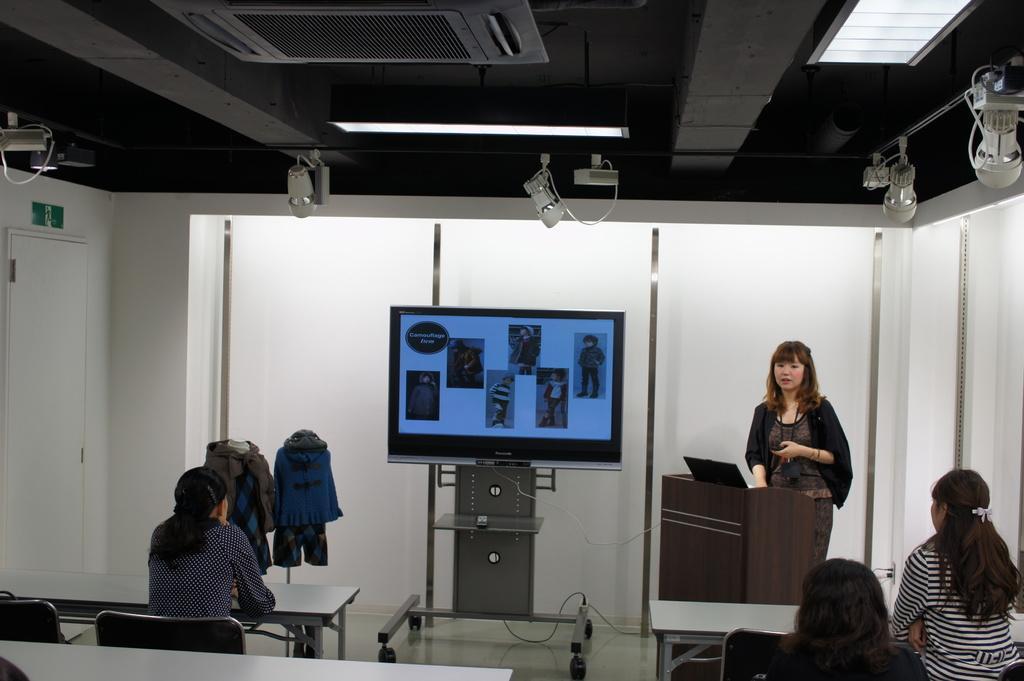Can you describe this image briefly? In this picture I can see few women sitting in the chairs and I can see a woman standing at a podium and I can see a laptop on the podium and a television displaying few pictures and I can see couple of mannequins with clothes and I can see few lights on the ceiling and I can see tables. 